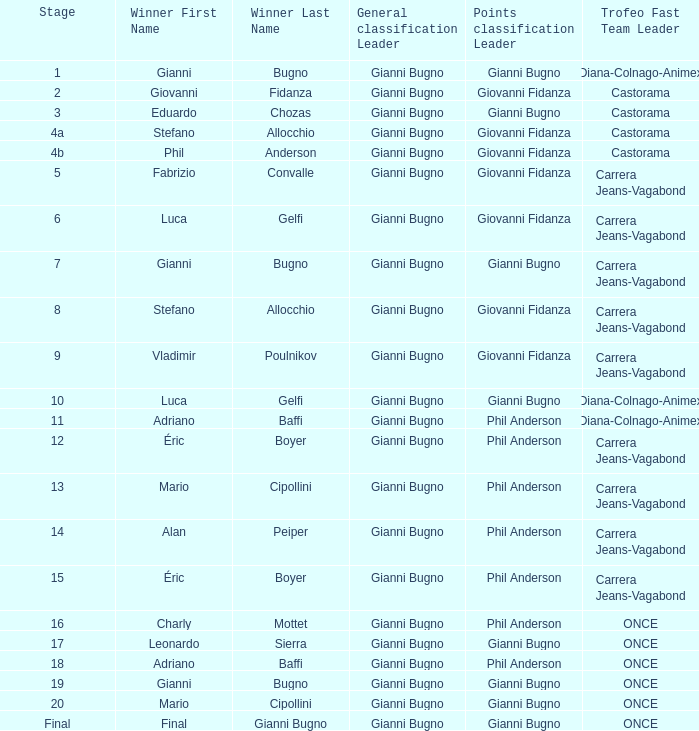Could you parse the entire table as a dict? {'header': ['Stage', 'Winner First Name', 'Winner Last Name', 'General classification Leader', 'Points classification Leader', 'Trofeo Fast Team Leader'], 'rows': [['1', 'Gianni', 'Bugno', 'Gianni Bugno', 'Gianni Bugno', 'Diana-Colnago-Animex'], ['2', 'Giovanni', 'Fidanza', 'Gianni Bugno', 'Giovanni Fidanza', 'Castorama'], ['3', 'Eduardo', 'Chozas', 'Gianni Bugno', 'Gianni Bugno', 'Castorama'], ['4a', 'Stefano', 'Allocchio', 'Gianni Bugno', 'Giovanni Fidanza', 'Castorama'], ['4b', 'Phil', 'Anderson', 'Gianni Bugno', 'Giovanni Fidanza', 'Castorama'], ['5', 'Fabrizio', 'Convalle', 'Gianni Bugno', 'Giovanni Fidanza', 'Carrera Jeans-Vagabond'], ['6', 'Luca', 'Gelfi', 'Gianni Bugno', 'Giovanni Fidanza', 'Carrera Jeans-Vagabond'], ['7', 'Gianni', 'Bugno', 'Gianni Bugno', 'Gianni Bugno', 'Carrera Jeans-Vagabond'], ['8', 'Stefano', 'Allocchio', 'Gianni Bugno', 'Giovanni Fidanza', 'Carrera Jeans-Vagabond'], ['9', 'Vladimir', 'Poulnikov', 'Gianni Bugno', 'Giovanni Fidanza', 'Carrera Jeans-Vagabond'], ['10', 'Luca', 'Gelfi', 'Gianni Bugno', 'Gianni Bugno', 'Diana-Colnago-Animex'], ['11', 'Adriano', 'Baffi', 'Gianni Bugno', 'Phil Anderson', 'Diana-Colnago-Animex'], ['12', 'Éric', 'Boyer', 'Gianni Bugno', 'Phil Anderson', 'Carrera Jeans-Vagabond'], ['13', 'Mario', 'Cipollini', 'Gianni Bugno', 'Phil Anderson', 'Carrera Jeans-Vagabond'], ['14', 'Alan', 'Peiper', 'Gianni Bugno', 'Phil Anderson', 'Carrera Jeans-Vagabond'], ['15', 'Éric', 'Boyer', 'Gianni Bugno', 'Phil Anderson', 'Carrera Jeans-Vagabond'], ['16', 'Charly', 'Mottet', 'Gianni Bugno', 'Phil Anderson', 'ONCE'], ['17', 'Leonardo', 'Sierra', 'Gianni Bugno', 'Gianni Bugno', 'ONCE'], ['18', 'Adriano', 'Baffi', 'Gianni Bugno', 'Phil Anderson', 'ONCE'], ['19', 'Gianni', 'Bugno', 'Gianni Bugno', 'Gianni Bugno', 'ONCE'], ['20', 'Mario', 'Cipollini', 'Gianni Bugno', 'Gianni Bugno', 'ONCE'], ['Final', 'Final', 'Gianni Bugno', 'Gianni Bugno', 'Gianni Bugno', 'ONCE']]} Who is the points classification in stage 1? Gianni Bugno. 